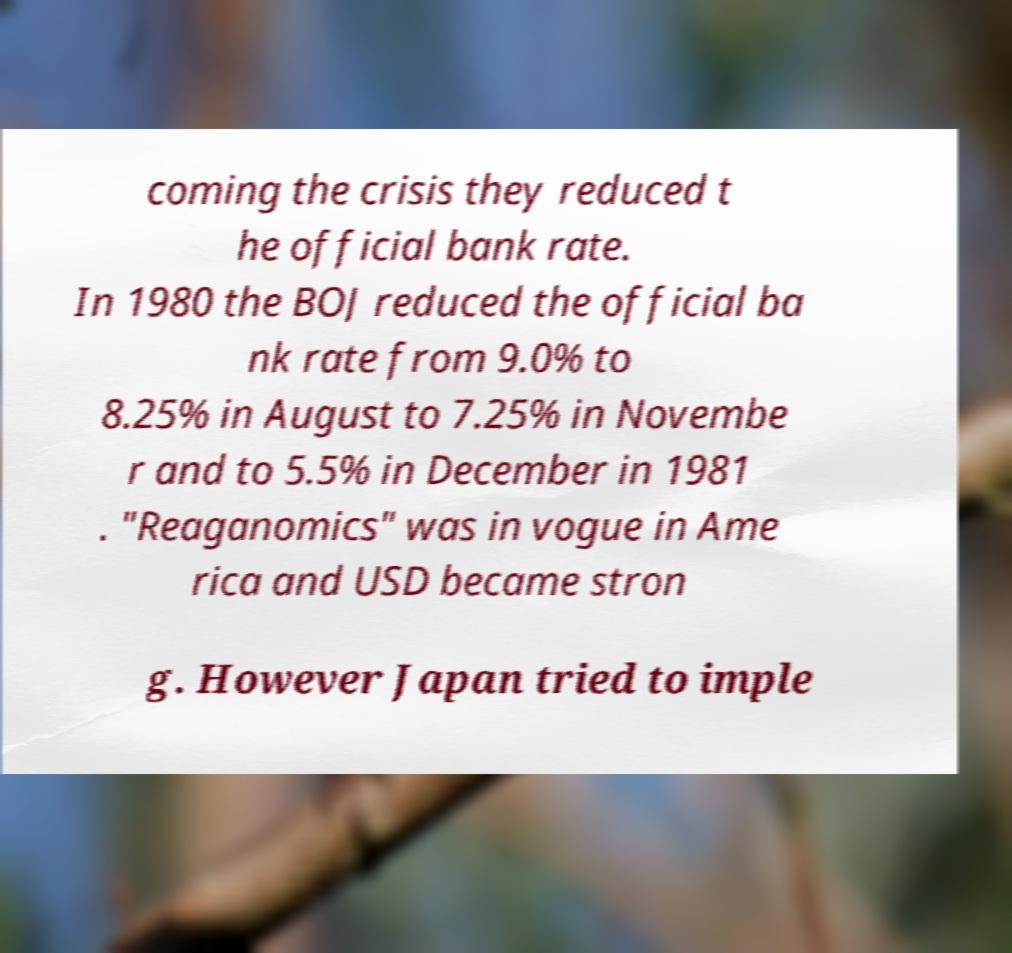Could you extract and type out the text from this image? coming the crisis they reduced t he official bank rate. In 1980 the BOJ reduced the official ba nk rate from 9.0% to 8.25% in August to 7.25% in Novembe r and to 5.5% in December in 1981 . "Reaganomics" was in vogue in Ame rica and USD became stron g. However Japan tried to imple 